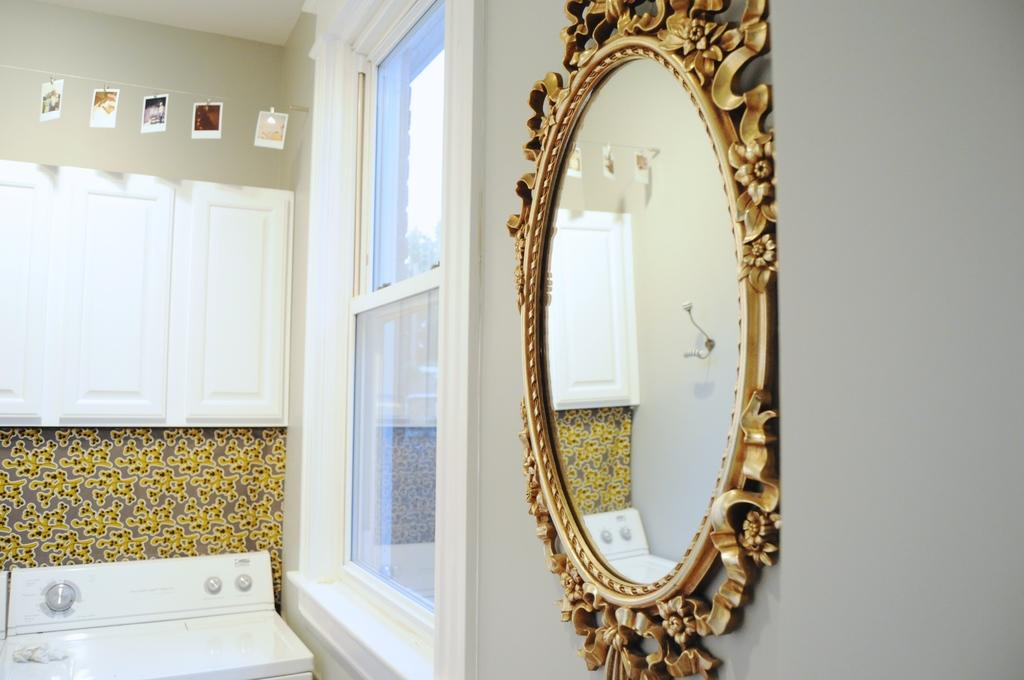What is located in the foreground of the image? There is a mirror and a window in the foreground of the image. How is the mirror positioned in the image? The mirror is attached to a wall. What type of appliance can be seen in the image? A washing machine is present in the image. What type of storage furniture is visible in the image? There are cupboards in the image. What is hanging from a rope in the image? There are photos hanging from a rope in the image. How many men are operating the pump in the image? There is no pump or men present in the image. What type of machine is visible in the image? There is no machine present in the image. 